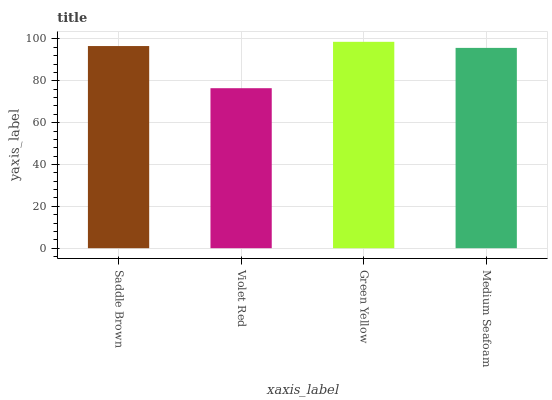Is Violet Red the minimum?
Answer yes or no. Yes. Is Green Yellow the maximum?
Answer yes or no. Yes. Is Green Yellow the minimum?
Answer yes or no. No. Is Violet Red the maximum?
Answer yes or no. No. Is Green Yellow greater than Violet Red?
Answer yes or no. Yes. Is Violet Red less than Green Yellow?
Answer yes or no. Yes. Is Violet Red greater than Green Yellow?
Answer yes or no. No. Is Green Yellow less than Violet Red?
Answer yes or no. No. Is Saddle Brown the high median?
Answer yes or no. Yes. Is Medium Seafoam the low median?
Answer yes or no. Yes. Is Medium Seafoam the high median?
Answer yes or no. No. Is Saddle Brown the low median?
Answer yes or no. No. 